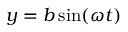Convert formula to latex. <formula><loc_0><loc_0><loc_500><loc_500>y = b \sin ( \omega t )</formula> 